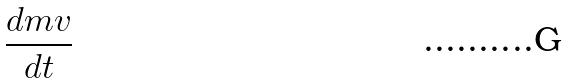Convert formula to latex. <formula><loc_0><loc_0><loc_500><loc_500>\frac { d m v } { d t }</formula> 